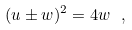Convert formula to latex. <formula><loc_0><loc_0><loc_500><loc_500>( u \pm w ) ^ { 2 } = 4 w \ ,</formula> 